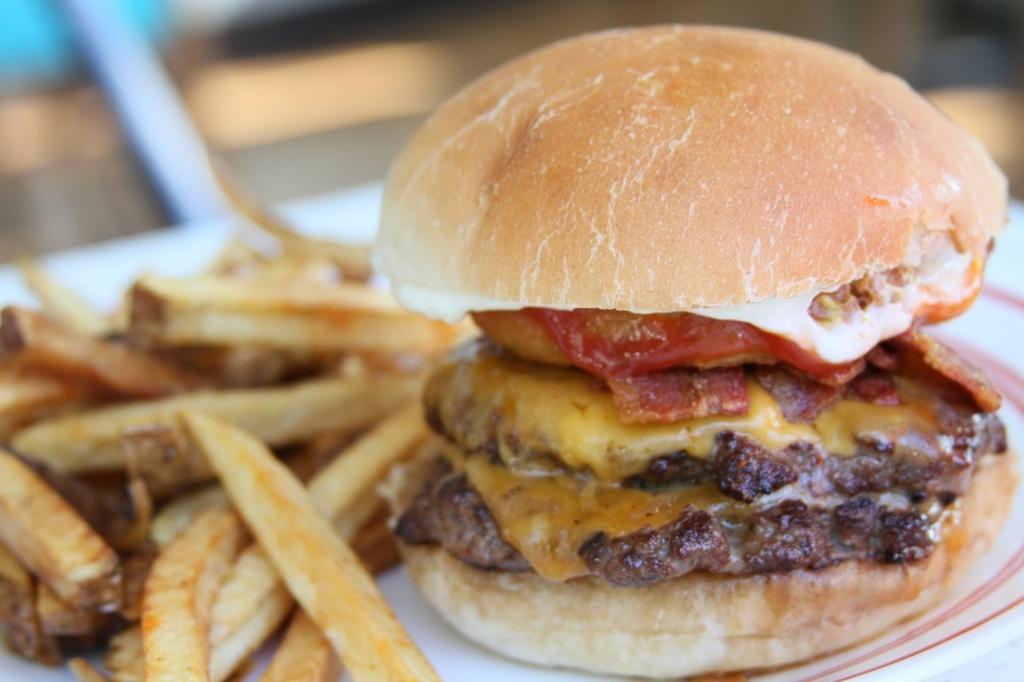How would you summarize this image in a sentence or two? In this image I can see burger and fries are on the plate. In the background of the image it is blurry. 